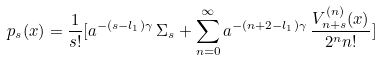Convert formula to latex. <formula><loc_0><loc_0><loc_500><loc_500>p _ { s } ( x ) = \frac { 1 } { s ! } [ a ^ { - ( s - l _ { 1 } ) \gamma } \, \Sigma _ { s } + \sum _ { n = 0 } ^ { \infty } a ^ { - ( n + 2 - l _ { 1 } ) \gamma } \, \frac { V ^ { ( n ) } _ { n + s } ( x ) } { 2 ^ { n } n ! } ]</formula> 